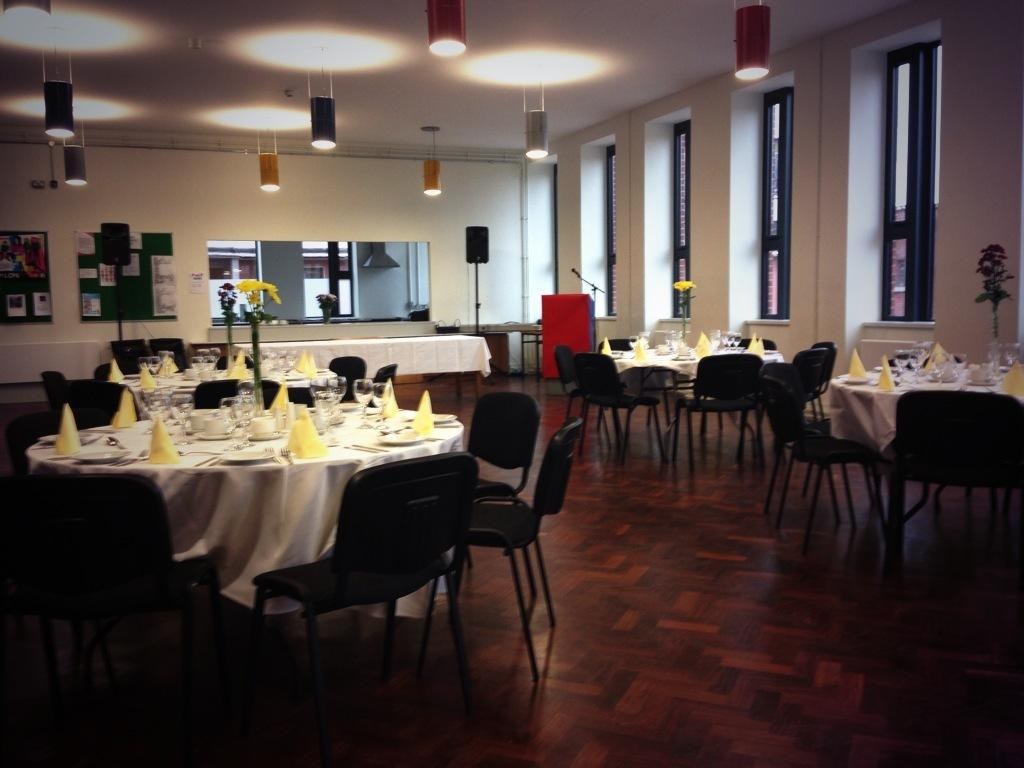What type of furniture is present on both sides of the image? There are tables and chairs on both sides of the image. What can be seen on the right side of the image? There are windows on the right side of the image. What type of lighting is present at the top side of the image? There are lamps at the top side of the image. How many card designs can be seen on the tables in the image? There is no mention of cards or card designs in the image; only tables, chairs, windows, and lamps are present. Are there any goldfish visible in the image? There is no mention of goldfish in the image; only tables, chairs, windows, and lamps are present. 